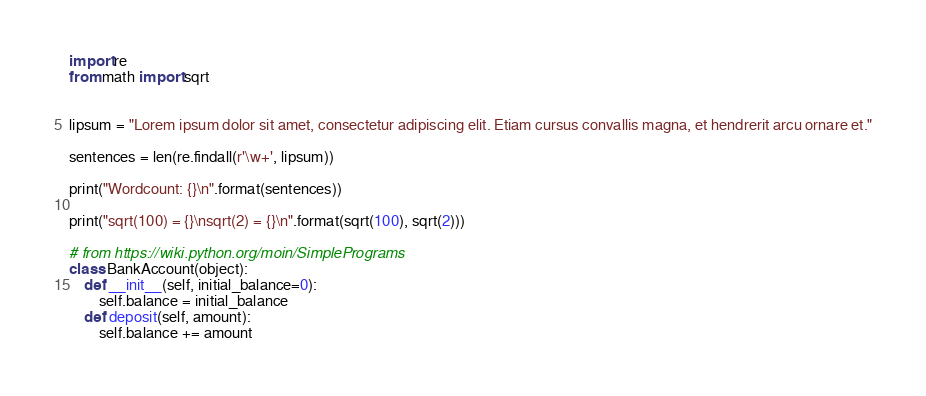Convert code to text. <code><loc_0><loc_0><loc_500><loc_500><_Python_>import re
from math import sqrt


lipsum = "Lorem ipsum dolor sit amet, consectetur adipiscing elit. Etiam cursus convallis magna, et hendrerit arcu ornare et."

sentences = len(re.findall(r'\w+', lipsum))

print("Wordcount: {}\n".format(sentences))

print("sqrt(100) = {}\nsqrt(2) = {}\n".format(sqrt(100), sqrt(2)))

# from https://wiki.python.org/moin/SimplePrograms
class BankAccount(object):
    def __init__(self, initial_balance=0):
        self.balance = initial_balance
    def deposit(self, amount):
        self.balance += amount</code> 